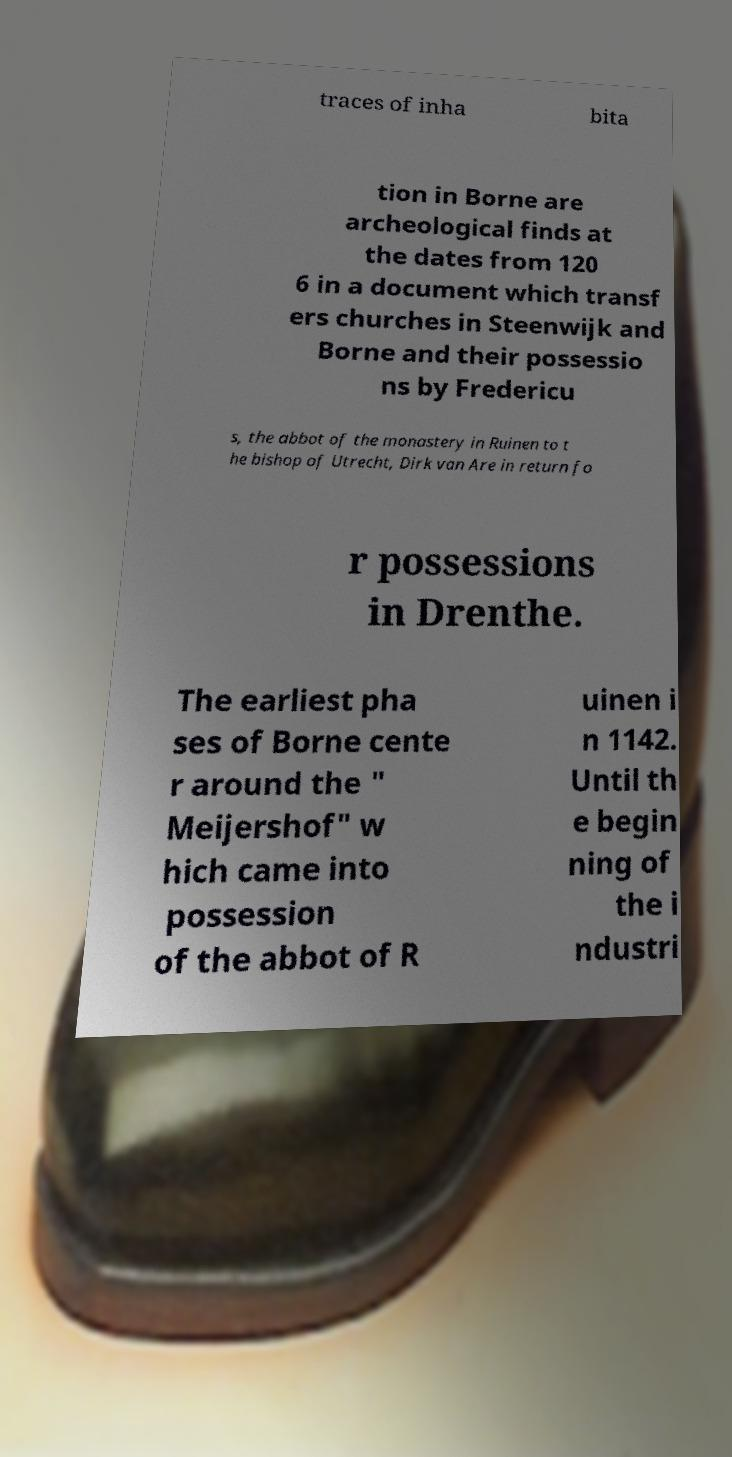Please identify and transcribe the text found in this image. traces of inha bita tion in Borne are archeological finds at the dates from 120 6 in a document which transf ers churches in Steenwijk and Borne and their possessio ns by Fredericu s, the abbot of the monastery in Ruinen to t he bishop of Utrecht, Dirk van Are in return fo r possessions in Drenthe. The earliest pha ses of Borne cente r around the " Meijershof" w hich came into possession of the abbot of R uinen i n 1142. Until th e begin ning of the i ndustri 